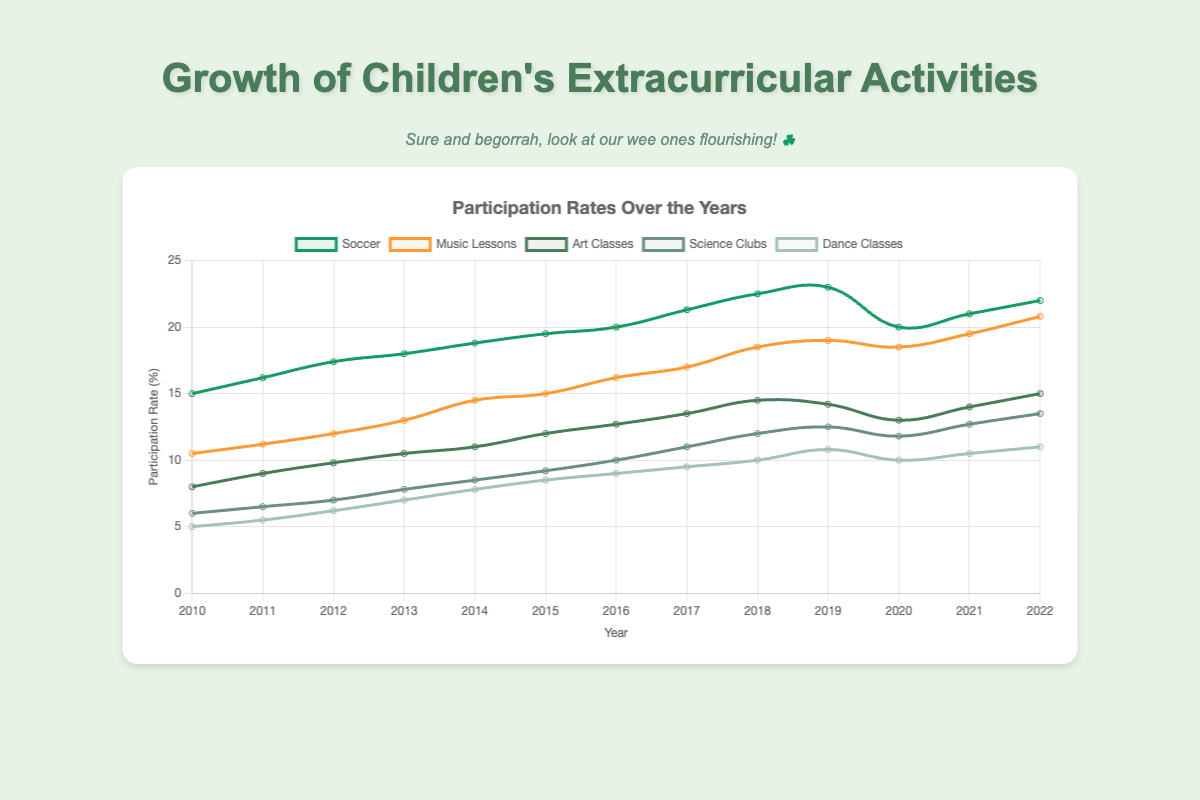What's the overall trend in soccer participation from 2010 to 2022? The soccer participation line plot shows a general upward trend from 15.0% in 2010 to 22.0% in 2022, with a slight drop in 2020 before resuming growth.
Answer: Upward Which activity had the highest participation rate in 2022? Observing the end data points in the plot, the soccer participation line is the highest at 22.0% in 2022.
Answer: Soccer In which year was the participation in dance classes equal to 8.5%? Examining the intersection of the dance classes line (light green) with the y-axis value of 8.5%, this occurs in 2015.
Answer: 2015 Compare the growth rates between music lessons and science clubs from 2010 to 2022. Which grew faster? Music lessons participation grew from 10.5% to 20.8% (a change of 10.3%), whereas science clubs participation grew from 6.0% to 13.5% (a change of 7.5%). Although both increased, music lessons saw a larger absolute increase.
Answer: Music lessons What was the participation rate for art classes and science clubs in 2019, and which was higher? In 2019, the data points show 14.2% for art classes and 12.5% for science clubs. Art classes had a higher participation rate.
Answer: Art classes How many activities had participation rates greater than 15% in 2022? The participation rates for 2022 show soccer (22.0%), music lessons (20.8%), art classes (15.0%), and science clubs (13.5%). Therefore, three activities had rates greater than 15%.
Answer: 3 What was the combined participation rate for soccer and music lessons in 2010? The participation rates for soccer and music lessons in 2010 were 15.0% and 10.5%. The combined rate is 15.0 + 10.5 = 25.5%.
Answer: 25.5% Which activity experienced a decline in participation rate between 2018 and 2019? The dance classes participation line shows a decrease from 10.8% in 2018 to 10.0% in 2019.
Answer: Dance classes By how much did the participation rate in art classes increase from 2010 to 2022? The rate for art classes grew from 8.0% in 2010 to 15.0% in 2022. The increase is 15.0 - 8.0 = 7.0%.
Answer: 7.0 Which activity has the most consistent upward trend throughout the years with no declines? The music lessons line shows a steady increase from 10.5% in 2010 to 20.8% in 2022 with no dips.
Answer: Music lessons 